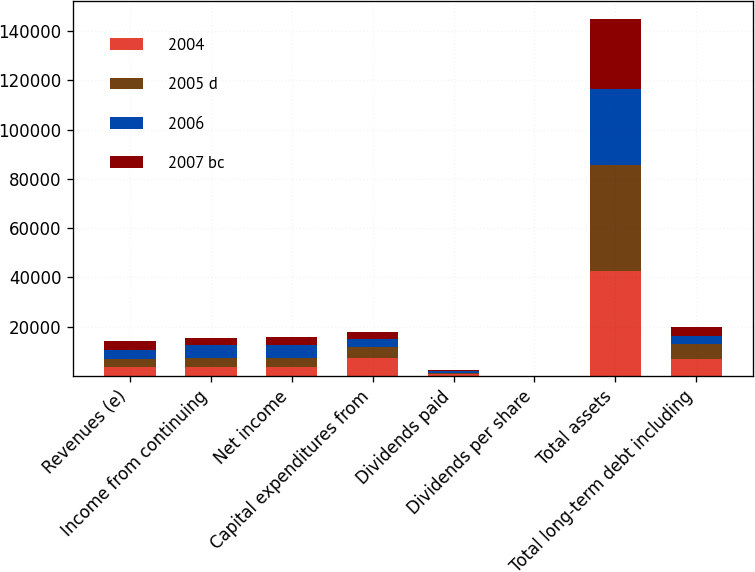<chart> <loc_0><loc_0><loc_500><loc_500><stacked_bar_chart><ecel><fcel>Revenues (e)<fcel>Income from continuing<fcel>Net income<fcel>Capital expenditures from<fcel>Dividends paid<fcel>Dividends per share<fcel>Total assets<fcel>Total long-term debt including<nl><fcel>2004<fcel>3528<fcel>3528<fcel>3528<fcel>7146<fcel>681<fcel>0.96<fcel>42686<fcel>7087<nl><fcel>2005 d<fcel>3528<fcel>3948<fcel>3956<fcel>4466<fcel>637<fcel>0.92<fcel>42746<fcel>6084<nl><fcel>2006<fcel>3528<fcel>4957<fcel>5234<fcel>3433<fcel>547<fcel>0.76<fcel>30831<fcel>3061<nl><fcel>2007 bc<fcel>3528<fcel>3006<fcel>3032<fcel>2796<fcel>436<fcel>0.6<fcel>28498<fcel>3698<nl></chart> 